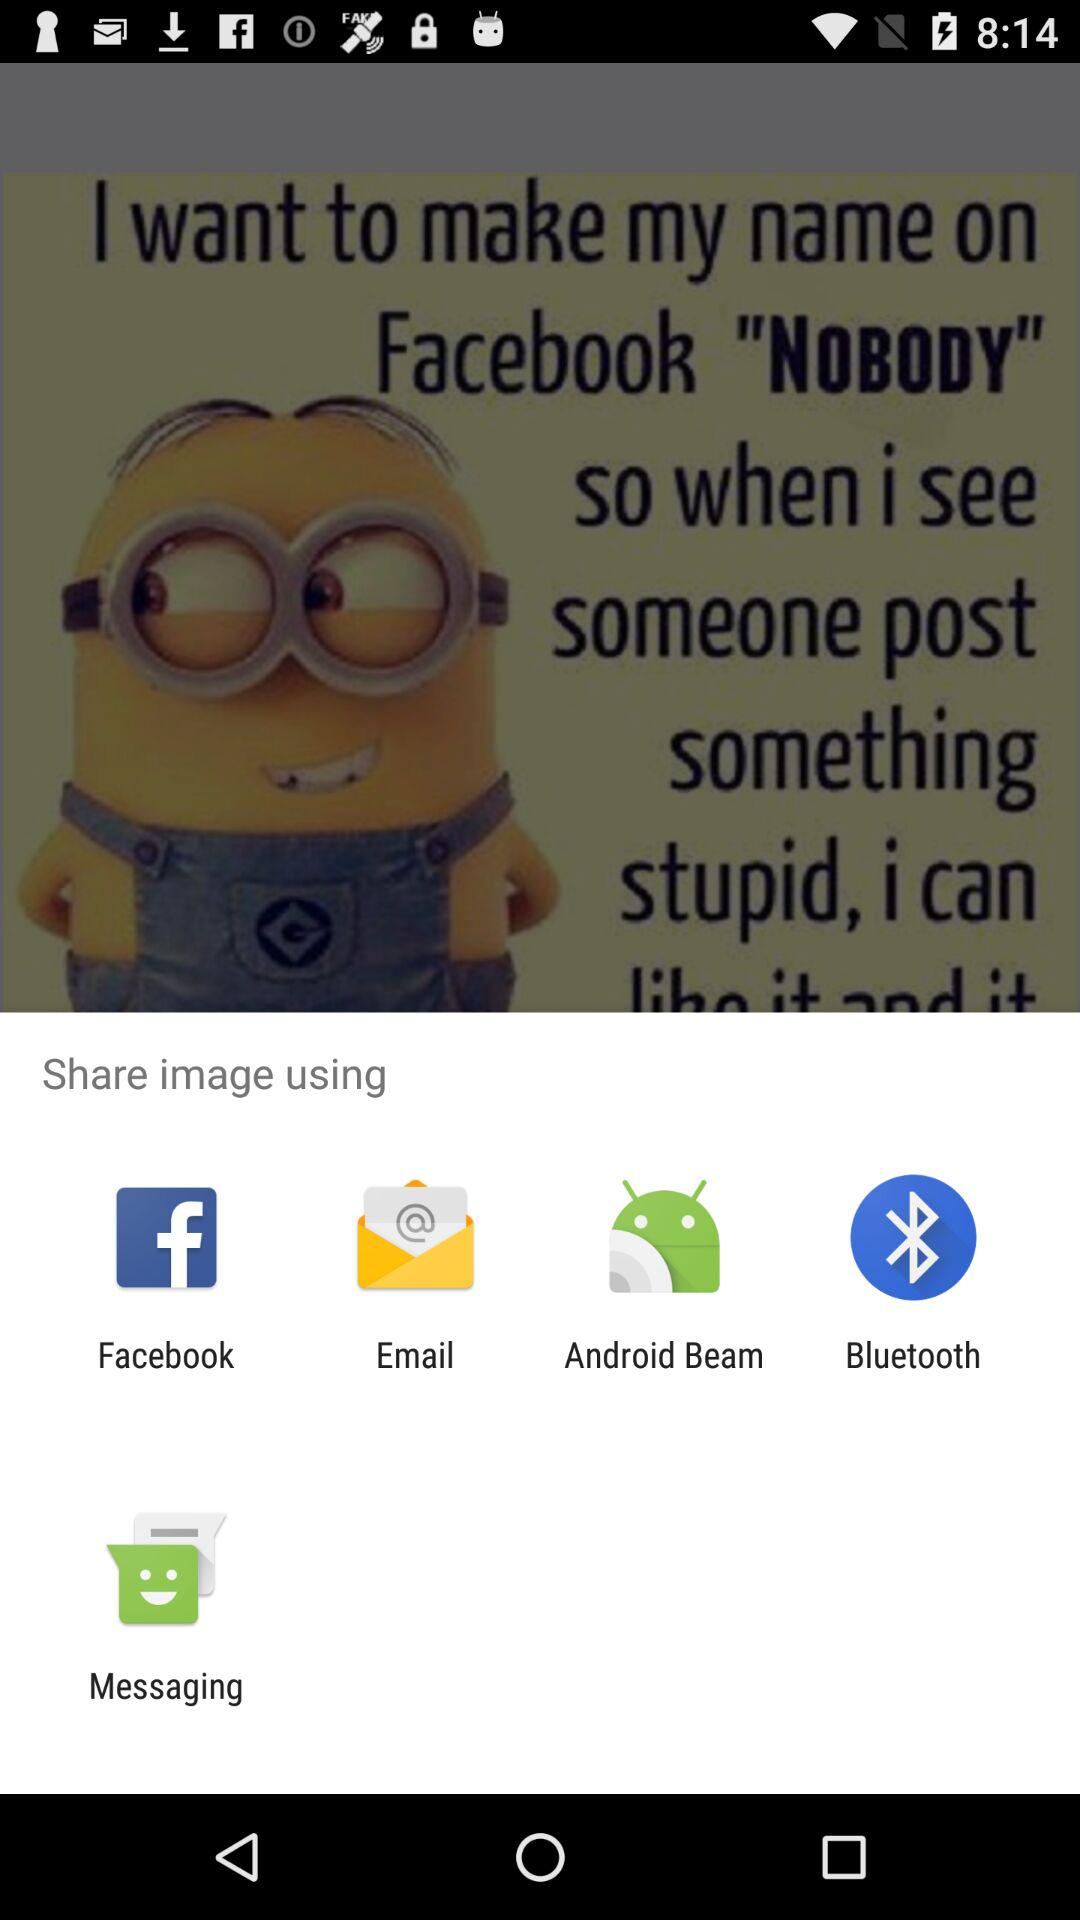What are the available sharing options? The available options are "Facebook", "Email", "Android beam", "Bluetooth" and "Messaging". 